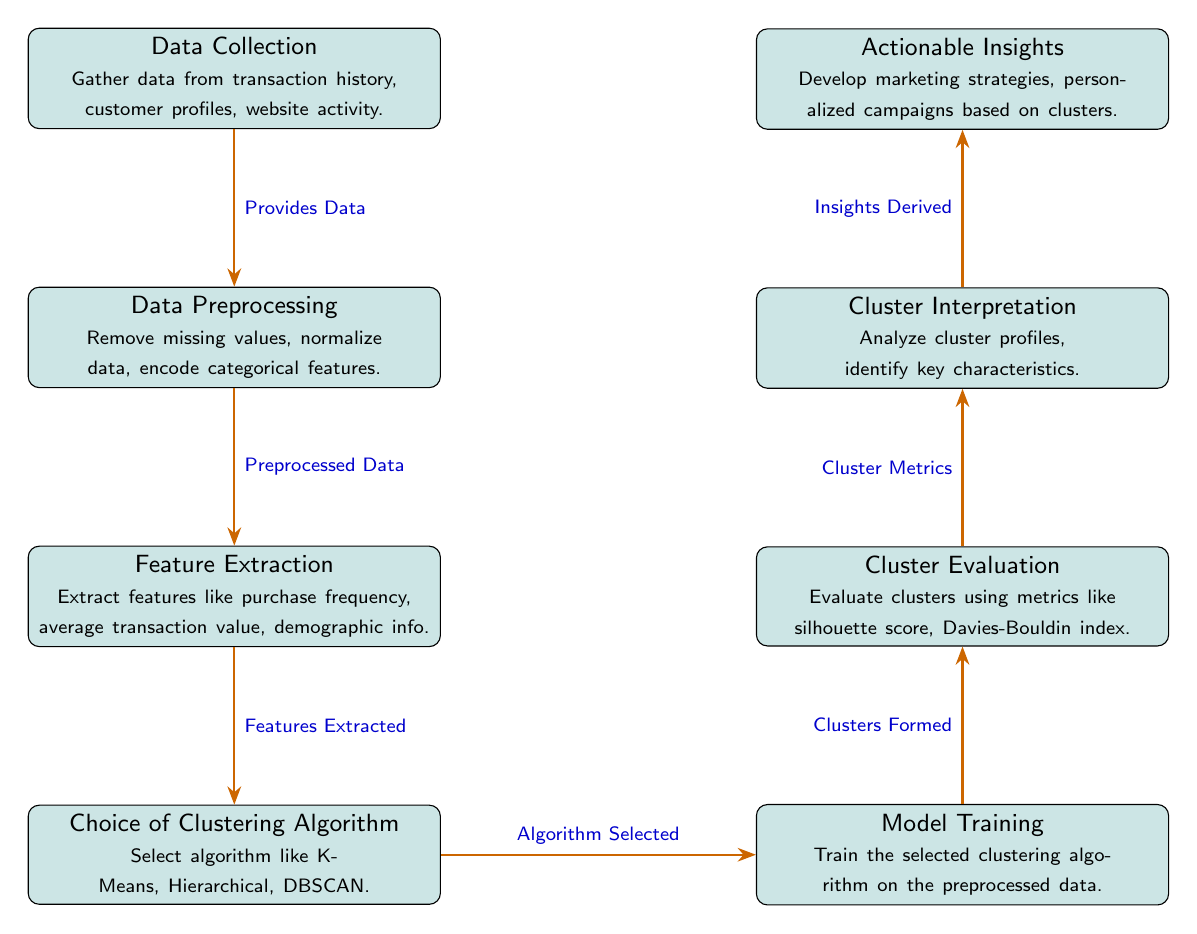What is the first step in customer segmentation? The first step in the diagram is "Data Collection," which involves gathering transaction history, customer profiles, and website activity.
Answer: Data Collection What type of algorithm can be chosen after feature extraction? After feature extraction, the diagram specifies that one can choose algorithms such as K-Means, Hierarchical, or DBSCAN.
Answer: Clustering Algorithm How many total steps are represented in the diagram? The diagram illustrates a total of eight steps, from Data Collection to Actionable Insights.
Answer: Eight What type of features are extracted in this process? The features extracted include purchase frequency, average transaction value, and demographic information.
Answer: Purchase frequency, average transaction value, demographic info What is the relationship between "Model Training" and "Cluster Evaluation"? The relationship is that "Model Training" forms the clusters, which are then evaluated in "Cluster Evaluation" using metrics.
Answer: Clusters Formed - Cluster Metrics How does the process move from "Cluster Interpretation" to "Actionable Insights"? The process moves from "Cluster Interpretation" to "Actionable Insights" by analyzing cluster profiles to derive insights that inform marketing strategies.
Answer: Insights Derived What metrics are used for cluster evaluation? The metrics used for evaluation include silhouette score and Davies-Bouldin index, which help assess cluster quality.
Answer: Silhouette score, Davies-Bouldin index Which step comes directly after "Choice of Clustering Algorithm"? The step that comes directly after "Choice of Clustering Algorithm" is "Model Training." This indicates that after selecting an algorithm, training occurs using the preprocessed data.
Answer: Model Training 